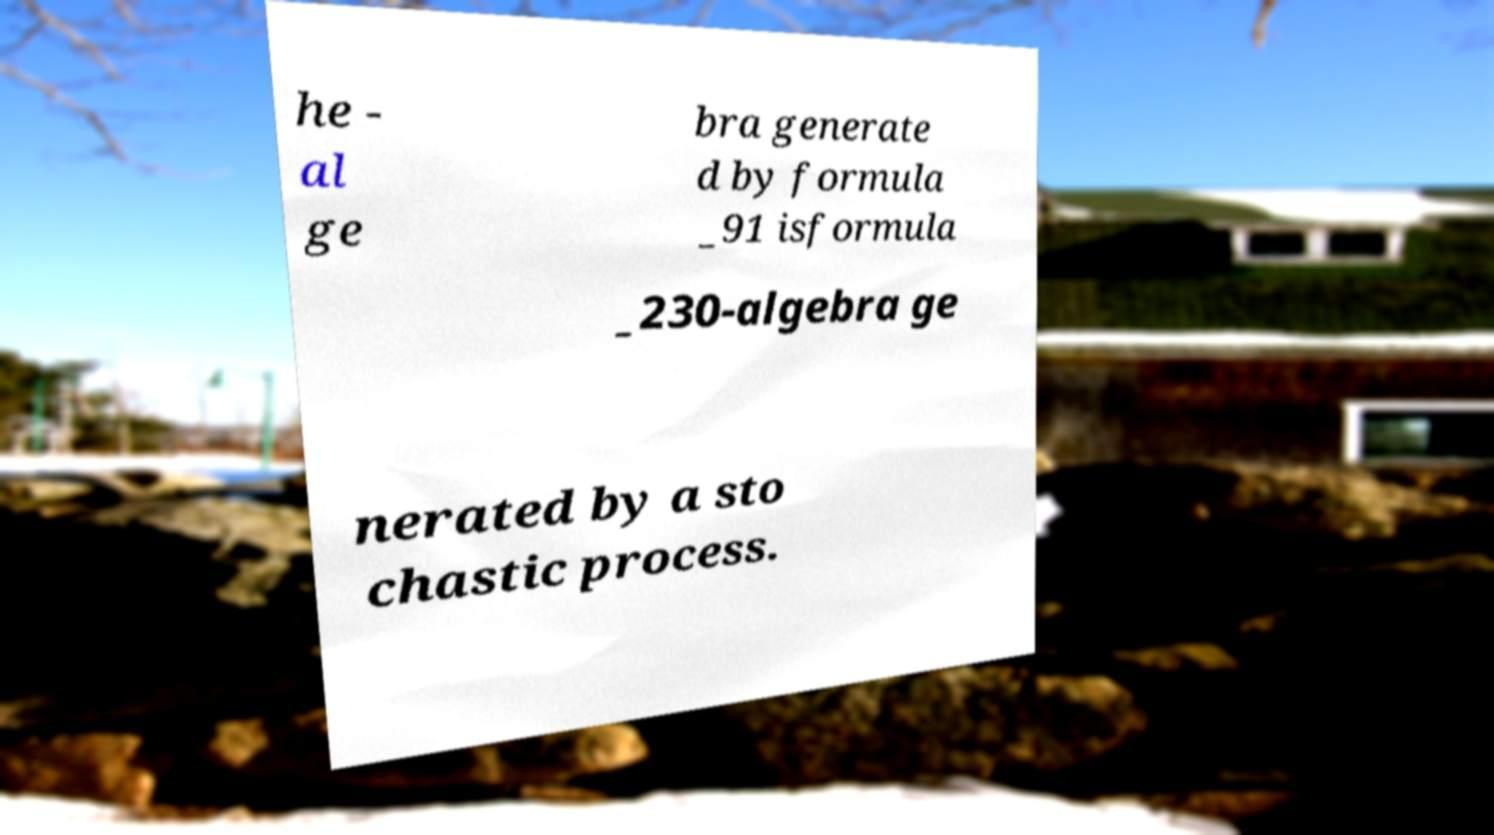There's text embedded in this image that I need extracted. Can you transcribe it verbatim? he - al ge bra generate d by formula _91 isformula _230-algebra ge nerated by a sto chastic process. 